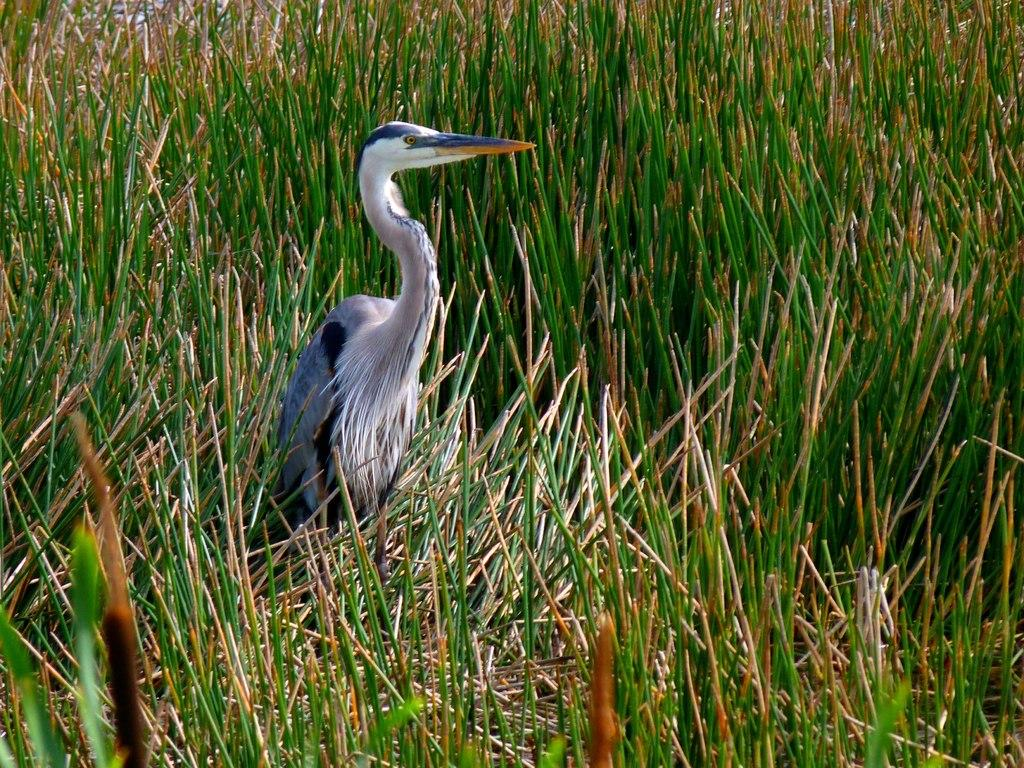What type of bird is in the image? There is a crane bird in the image. What is the crane bird standing on? The crane bird is standing in grass plants. What type of event is happening in the image? There is no event happening in the image; it simply shows a crane bird standing in grass plants. Can you see a bike in the image? No, there is no bike present in the image. 